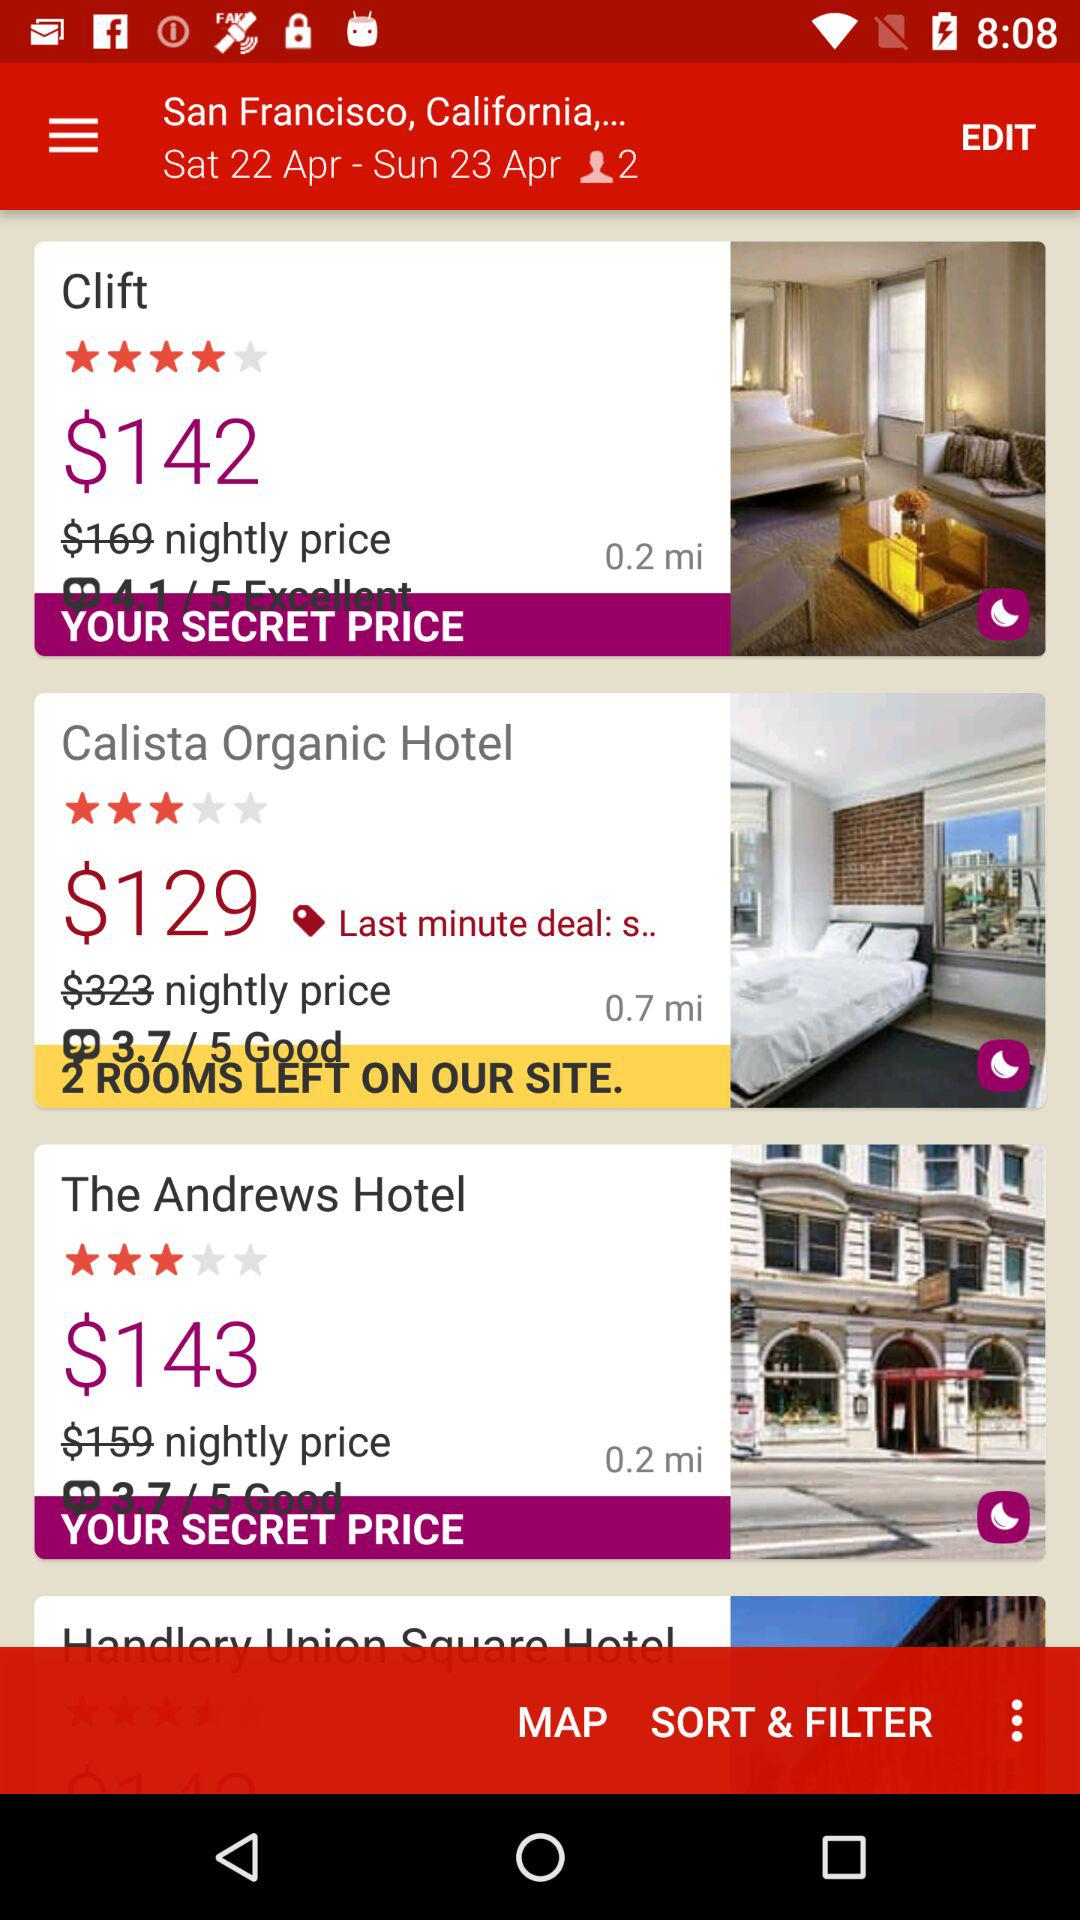When was the last deal of Calista Organic Hotel?
When the provided information is insufficient, respond with <no answer>. <no answer> 